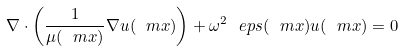<formula> <loc_0><loc_0><loc_500><loc_500>\nabla \cdot \left ( \frac { 1 } { \mu ( \ m x ) } \nabla u ( \ m x ) \right ) + \omega ^ { 2 } \ e p s ( \ m x ) u ( \ m x ) = 0</formula> 